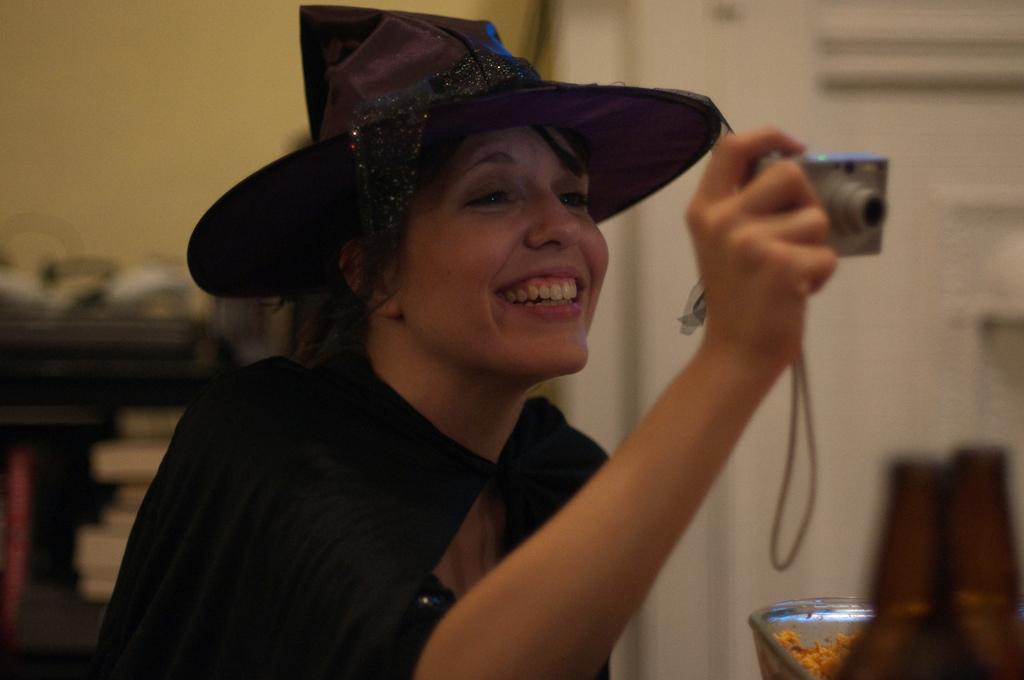Who is present in the image? There is a woman in the image. What is the woman doing in the image? The woman is smiling and holding a camera. Can you describe the background of the image? The background of the image is blurry. What can be seen on the right side of the image? There are objects on the right side of the image. What type of jam is being spread on the canvas in the image? There is no jam or canvas present in the image. 